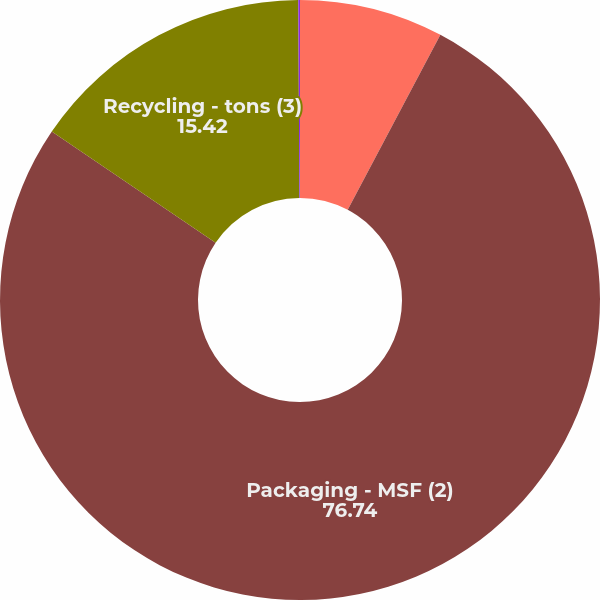Convert chart. <chart><loc_0><loc_0><loc_500><loc_500><pie_chart><fcel>Containerboard - tons (1)<fcel>Packaging - MSF (2)<fcel>Recycling - tons (3)<fcel>Kraft bags and sacks - tons<nl><fcel>7.75%<fcel>76.74%<fcel>15.42%<fcel>0.09%<nl></chart> 